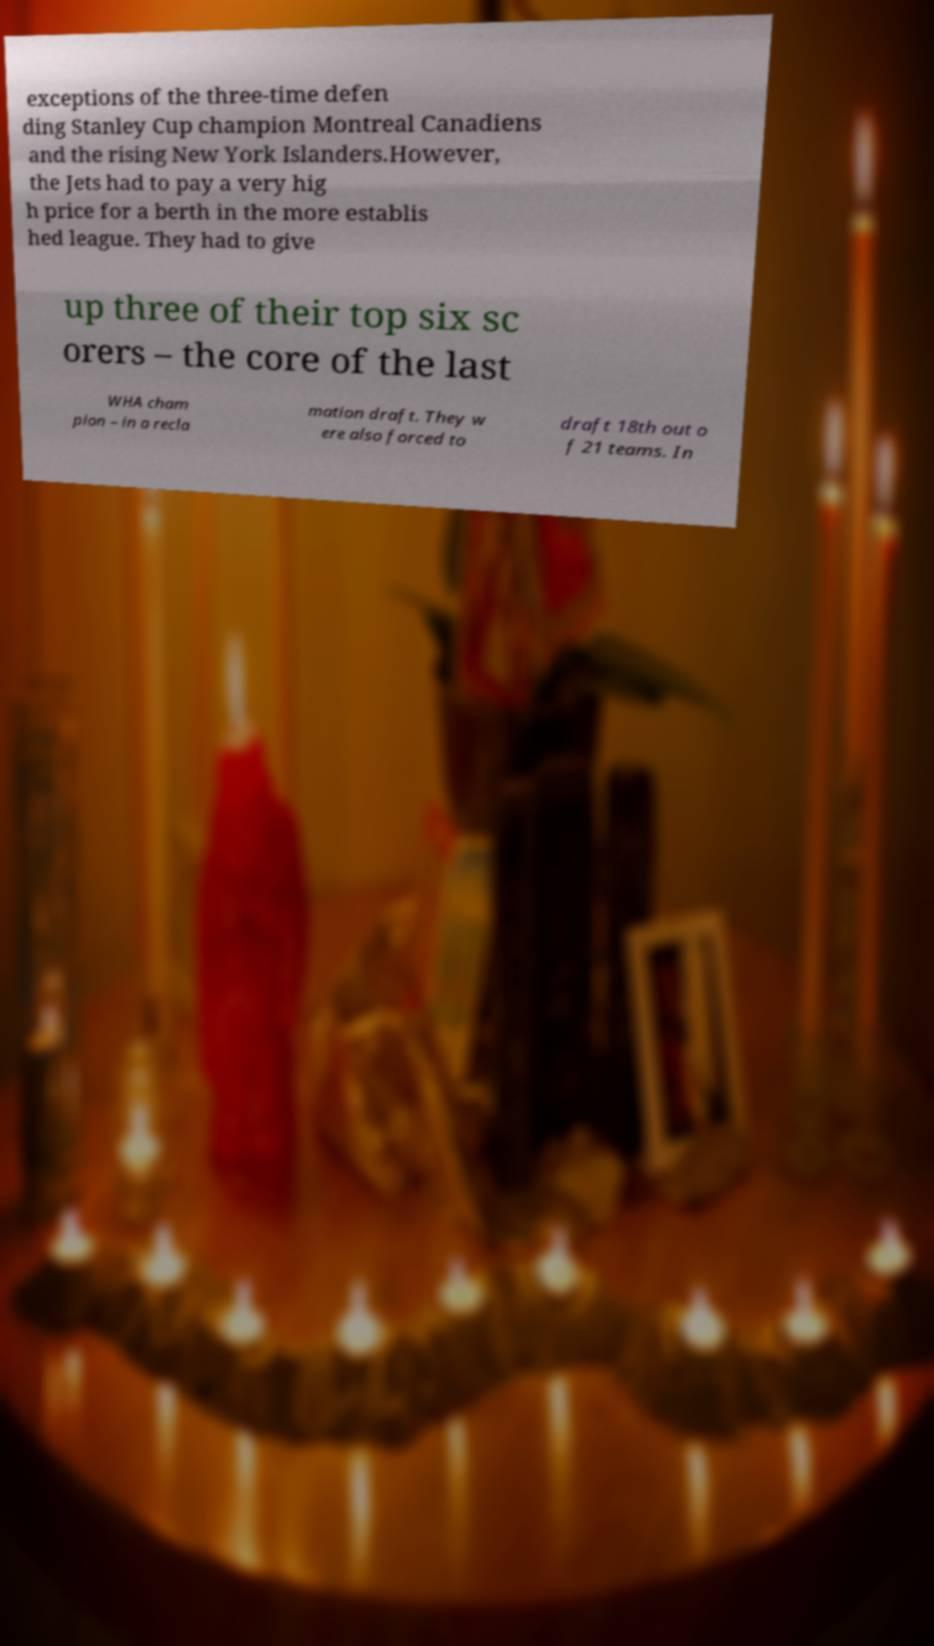There's text embedded in this image that I need extracted. Can you transcribe it verbatim? exceptions of the three-time defen ding Stanley Cup champion Montreal Canadiens and the rising New York Islanders.However, the Jets had to pay a very hig h price for a berth in the more establis hed league. They had to give up three of their top six sc orers – the core of the last WHA cham pion – in a recla mation draft. They w ere also forced to draft 18th out o f 21 teams. In 